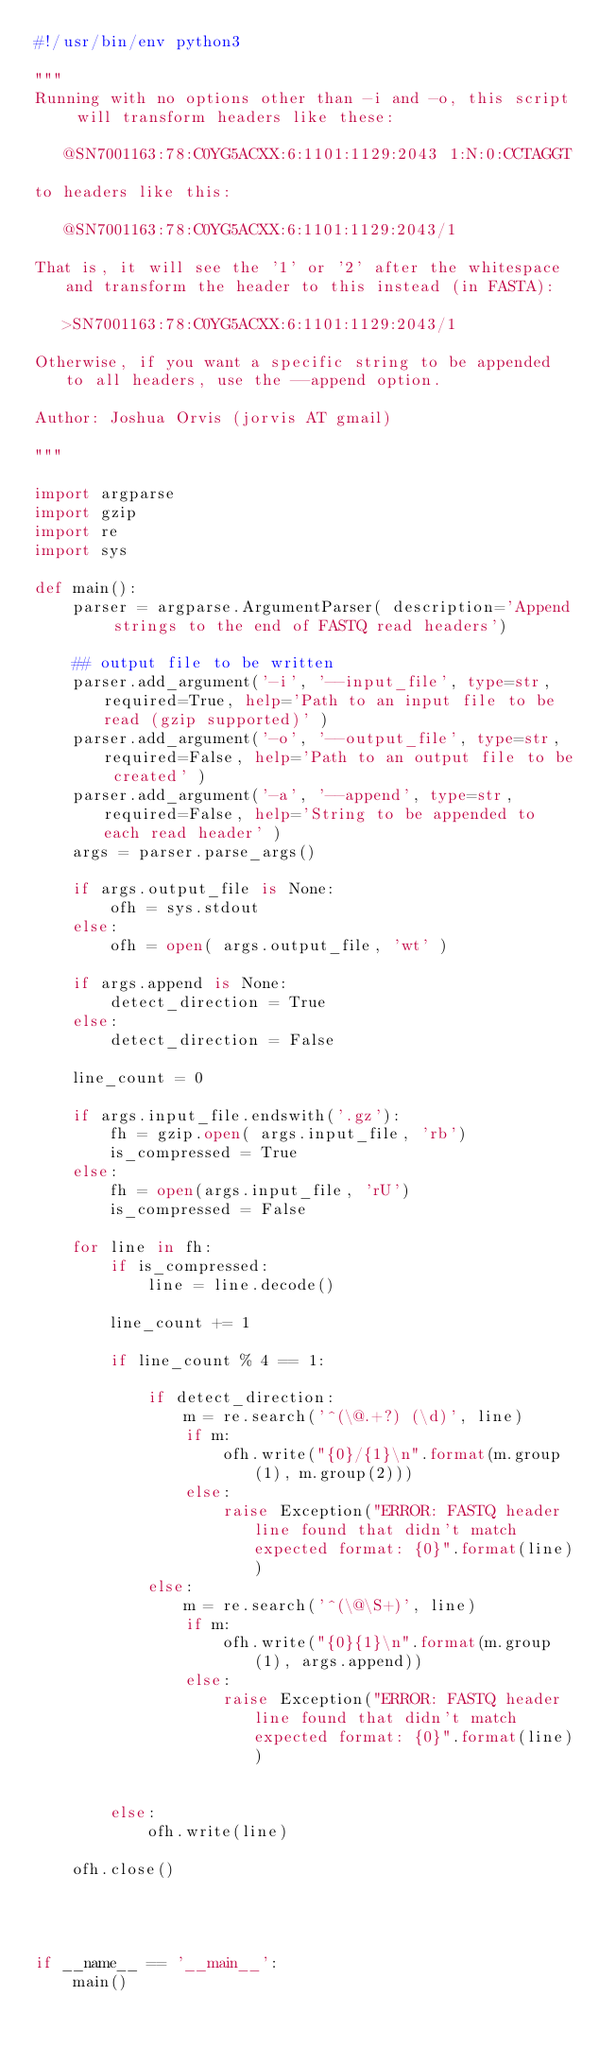<code> <loc_0><loc_0><loc_500><loc_500><_Python_>#!/usr/bin/env python3

"""
Running with no options other than -i and -o, this script will transform headers like these:

   @SN7001163:78:C0YG5ACXX:6:1101:1129:2043 1:N:0:CCTAGGT

to headers like this:

   @SN7001163:78:C0YG5ACXX:6:1101:1129:2043/1

That is, it will see the '1' or '2' after the whitespace and transform the header to this instead (in FASTA):

   >SN7001163:78:C0YG5ACXX:6:1101:1129:2043/1

Otherwise, if you want a specific string to be appended to all headers, use the --append option.

Author: Joshua Orvis (jorvis AT gmail)

"""

import argparse
import gzip
import re
import sys

def main():
    parser = argparse.ArgumentParser( description='Append strings to the end of FASTQ read headers')

    ## output file to be written
    parser.add_argument('-i', '--input_file', type=str, required=True, help='Path to an input file to be read (gzip supported)' )
    parser.add_argument('-o', '--output_file', type=str, required=False, help='Path to an output file to be created' )
    parser.add_argument('-a', '--append', type=str, required=False, help='String to be appended to each read header' )
    args = parser.parse_args()

    if args.output_file is None:
        ofh = sys.stdout
    else:
        ofh = open( args.output_file, 'wt' )

    if args.append is None:
        detect_direction = True
    else:
        detect_direction = False
        
    line_count = 0

    if args.input_file.endswith('.gz'):
        fh = gzip.open( args.input_file, 'rb')
        is_compressed = True
    else:
        fh = open(args.input_file, 'rU')
        is_compressed = False

    for line in fh:
        if is_compressed:
            line = line.decode()
        
        line_count += 1

        if line_count % 4 == 1:

            if detect_direction:
                m = re.search('^(\@.+?) (\d)', line)
                if m:
                    ofh.write("{0}/{1}\n".format(m.group(1), m.group(2)))
                else:
                    raise Exception("ERROR: FASTQ header line found that didn't match expected format: {0}".format(line))
            else:
                m = re.search('^(\@\S+)', line)
                if m:
                    ofh.write("{0}{1}\n".format(m.group(1), args.append))
                else:
                    raise Exception("ERROR: FASTQ header line found that didn't match expected format: {0}".format(line))

            
        else:
            ofh.write(line)
        
    ofh.close()




if __name__ == '__main__':
    main()







</code> 